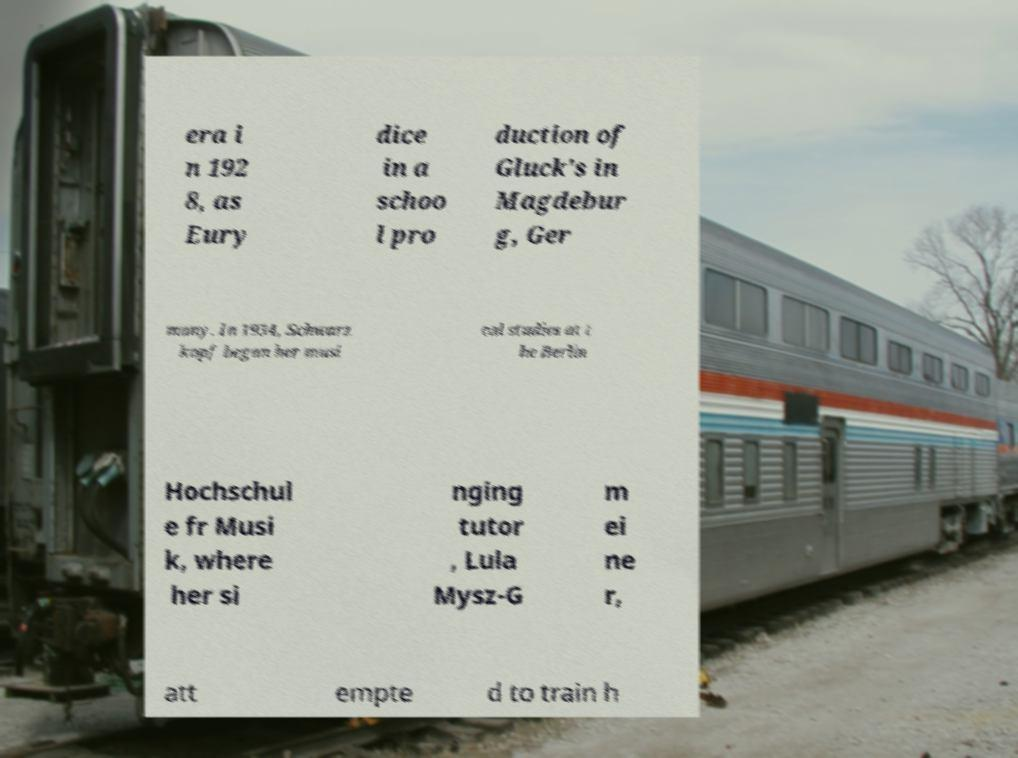Please read and relay the text visible in this image. What does it say? era i n 192 8, as Eury dice in a schoo l pro duction of Gluck's in Magdebur g, Ger many. In 1934, Schwarz kopf began her musi cal studies at t he Berlin Hochschul e fr Musi k, where her si nging tutor , Lula Mysz-G m ei ne r, att empte d to train h 